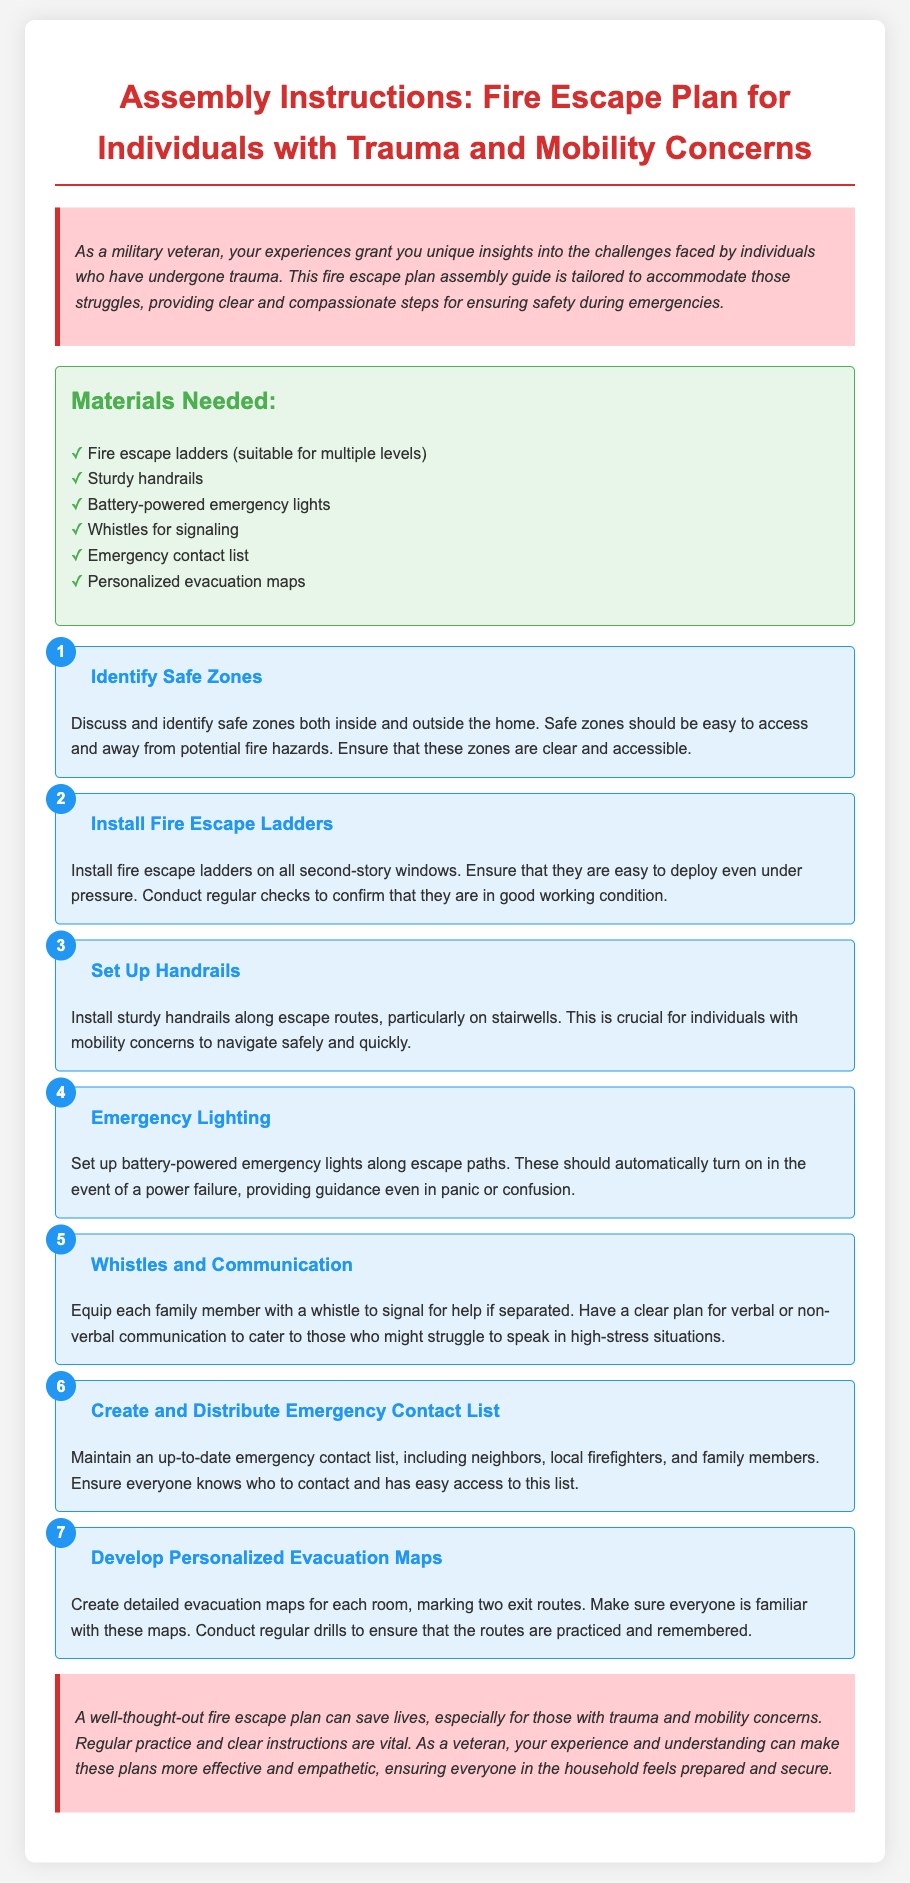What is the title of the document? The title of the document is the main heading that introduces the content, which is "Assembly Instructions: Fire Escape Plan for Individuals with Trauma and Mobility Concerns."
Answer: Assembly Instructions: Fire Escape Plan for Individuals with Trauma and Mobility Concerns How many materials are listed? The number of materials is counted by listing each item under the "Materials Needed" section, which includes six items.
Answer: 6 What is the first step in the escape plan? The first step in the assembly instructions is indicated in the steps section, which is to "Identify Safe Zones."
Answer: Identify Safe Zones What should be installed on all second-story windows? The specific item that should be installed on all second-story windows, as mentioned in the steps, is "fire escape ladders."
Answer: fire escape ladders Why is it important to set up handrails? The importance of setting up handrails is highlighted for a specific group of individuals, stating it is "crucial for individuals with mobility concerns."
Answer: individuals with mobility concerns What is one method of communication suggested for emergencies? One method suggested for communication during emergencies, as mentioned in the steps, is to provide "whistles for signaling."
Answer: whistles for signaling What is the purpose of the battery-powered emergency lights? The purpose of the battery-powered emergency lights is described as providing "guidance even in panic or confusion."
Answer: guidance even in panic or confusion How often should the evacuation maps be practiced? The document suggests that evacuation maps should be practiced "regularly" to ensure familiarity.
Answer: regularly 